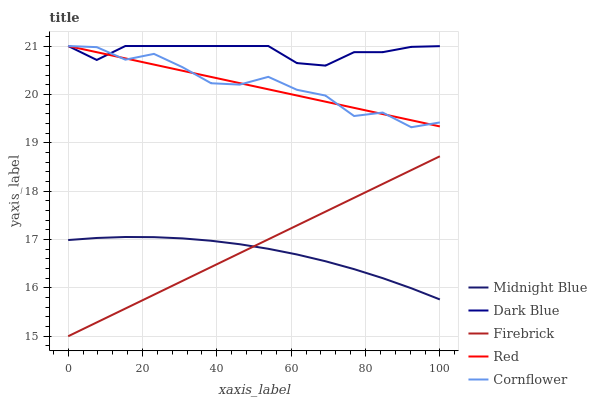Does Midnight Blue have the minimum area under the curve?
Answer yes or no. Yes. Does Dark Blue have the maximum area under the curve?
Answer yes or no. Yes. Does Firebrick have the minimum area under the curve?
Answer yes or no. No. Does Firebrick have the maximum area under the curve?
Answer yes or no. No. Is Firebrick the smoothest?
Answer yes or no. Yes. Is Cornflower the roughest?
Answer yes or no. Yes. Is Midnight Blue the smoothest?
Answer yes or no. No. Is Midnight Blue the roughest?
Answer yes or no. No. Does Firebrick have the lowest value?
Answer yes or no. Yes. Does Midnight Blue have the lowest value?
Answer yes or no. No. Does Cornflower have the highest value?
Answer yes or no. Yes. Does Firebrick have the highest value?
Answer yes or no. No. Is Midnight Blue less than Cornflower?
Answer yes or no. Yes. Is Dark Blue greater than Firebrick?
Answer yes or no. Yes. Does Red intersect Dark Blue?
Answer yes or no. Yes. Is Red less than Dark Blue?
Answer yes or no. No. Is Red greater than Dark Blue?
Answer yes or no. No. Does Midnight Blue intersect Cornflower?
Answer yes or no. No. 